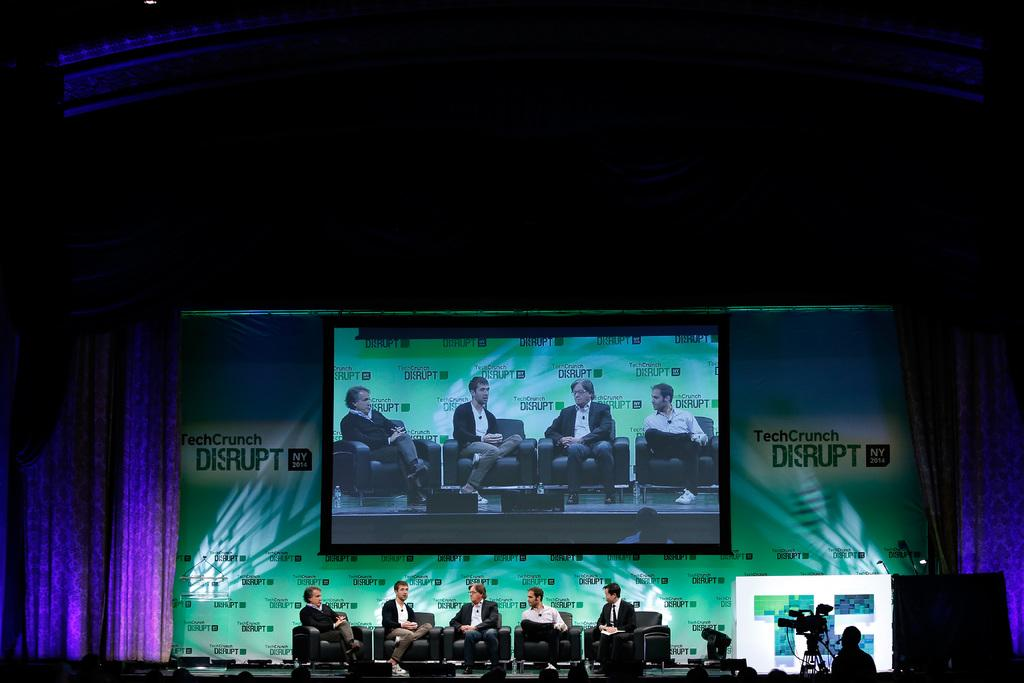<image>
Relay a brief, clear account of the picture shown. A bunch of men on a stage with a sign that says tech crunch disrupt. 